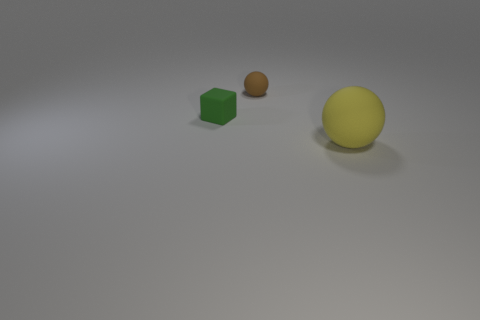Add 3 large objects. How many objects exist? 6 Subtract all cubes. How many objects are left? 2 Add 1 large gray metallic cylinders. How many large gray metallic cylinders exist? 1 Subtract 0 yellow cubes. How many objects are left? 3 Subtract all blocks. Subtract all big yellow objects. How many objects are left? 1 Add 1 brown rubber things. How many brown rubber things are left? 2 